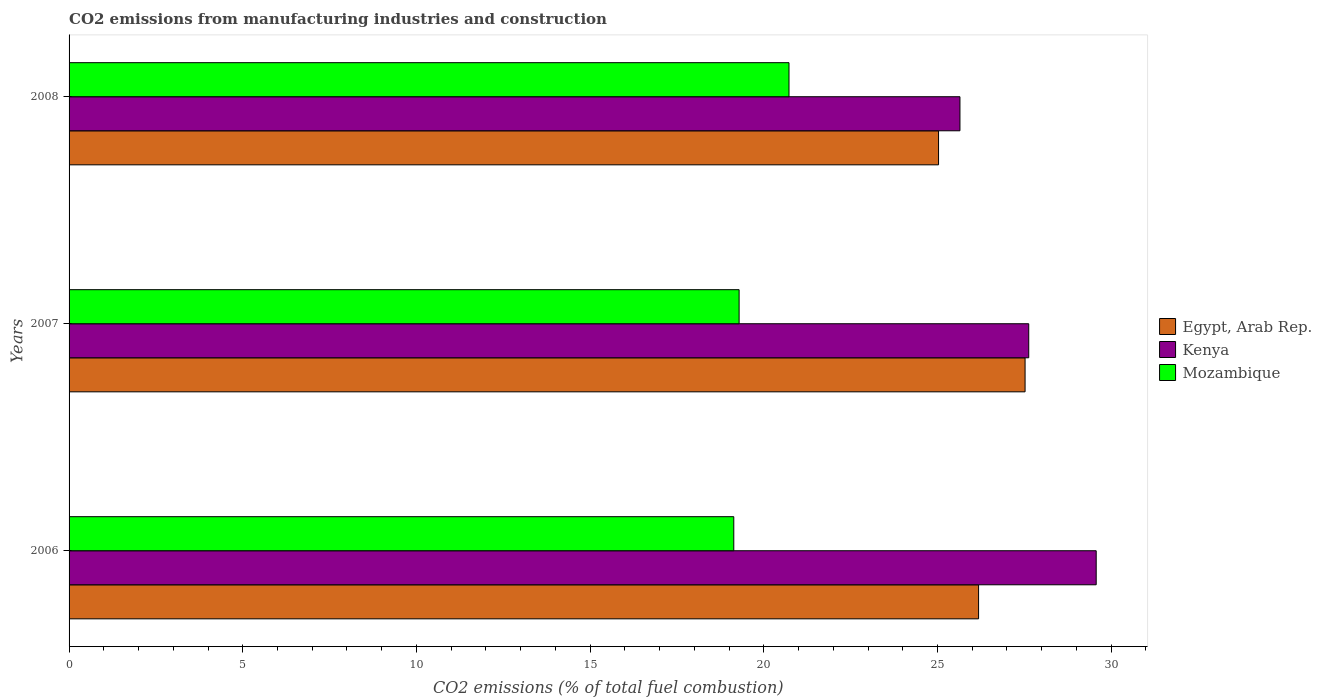Are the number of bars on each tick of the Y-axis equal?
Ensure brevity in your answer.  Yes. How many bars are there on the 3rd tick from the bottom?
Your response must be concise. 3. What is the label of the 3rd group of bars from the top?
Offer a terse response. 2006. What is the amount of CO2 emitted in Egypt, Arab Rep. in 2008?
Provide a succinct answer. 25.03. Across all years, what is the maximum amount of CO2 emitted in Egypt, Arab Rep.?
Offer a very short reply. 27.52. Across all years, what is the minimum amount of CO2 emitted in Egypt, Arab Rep.?
Provide a succinct answer. 25.03. In which year was the amount of CO2 emitted in Egypt, Arab Rep. minimum?
Offer a very short reply. 2008. What is the total amount of CO2 emitted in Kenya in the graph?
Your response must be concise. 82.84. What is the difference between the amount of CO2 emitted in Mozambique in 2006 and that in 2007?
Keep it short and to the point. -0.15. What is the difference between the amount of CO2 emitted in Egypt, Arab Rep. in 2006 and the amount of CO2 emitted in Mozambique in 2007?
Keep it short and to the point. 6.89. What is the average amount of CO2 emitted in Mozambique per year?
Provide a short and direct response. 19.72. In the year 2006, what is the difference between the amount of CO2 emitted in Kenya and amount of CO2 emitted in Mozambique?
Offer a terse response. 10.43. In how many years, is the amount of CO2 emitted in Kenya greater than 16 %?
Your answer should be compact. 3. What is the ratio of the amount of CO2 emitted in Mozambique in 2007 to that in 2008?
Keep it short and to the point. 0.93. Is the difference between the amount of CO2 emitted in Kenya in 2006 and 2007 greater than the difference between the amount of CO2 emitted in Mozambique in 2006 and 2007?
Give a very brief answer. Yes. What is the difference between the highest and the second highest amount of CO2 emitted in Mozambique?
Provide a short and direct response. 1.44. What is the difference between the highest and the lowest amount of CO2 emitted in Mozambique?
Offer a terse response. 1.59. In how many years, is the amount of CO2 emitted in Egypt, Arab Rep. greater than the average amount of CO2 emitted in Egypt, Arab Rep. taken over all years?
Provide a short and direct response. 1. What does the 2nd bar from the top in 2006 represents?
Provide a short and direct response. Kenya. What does the 3rd bar from the bottom in 2007 represents?
Ensure brevity in your answer.  Mozambique. Is it the case that in every year, the sum of the amount of CO2 emitted in Kenya and amount of CO2 emitted in Mozambique is greater than the amount of CO2 emitted in Egypt, Arab Rep.?
Your response must be concise. Yes. What is the difference between two consecutive major ticks on the X-axis?
Provide a succinct answer. 5. How many legend labels are there?
Provide a short and direct response. 3. How are the legend labels stacked?
Make the answer very short. Vertical. What is the title of the graph?
Give a very brief answer. CO2 emissions from manufacturing industries and construction. Does "Macedonia" appear as one of the legend labels in the graph?
Your response must be concise. No. What is the label or title of the X-axis?
Keep it short and to the point. CO2 emissions (% of total fuel combustion). What is the label or title of the Y-axis?
Give a very brief answer. Years. What is the CO2 emissions (% of total fuel combustion) in Egypt, Arab Rep. in 2006?
Ensure brevity in your answer.  26.18. What is the CO2 emissions (% of total fuel combustion) of Kenya in 2006?
Offer a very short reply. 29.57. What is the CO2 emissions (% of total fuel combustion) of Mozambique in 2006?
Your answer should be compact. 19.14. What is the CO2 emissions (% of total fuel combustion) in Egypt, Arab Rep. in 2007?
Your answer should be very brief. 27.52. What is the CO2 emissions (% of total fuel combustion) in Kenya in 2007?
Your answer should be compact. 27.63. What is the CO2 emissions (% of total fuel combustion) of Mozambique in 2007?
Keep it short and to the point. 19.29. What is the CO2 emissions (% of total fuel combustion) of Egypt, Arab Rep. in 2008?
Provide a succinct answer. 25.03. What is the CO2 emissions (% of total fuel combustion) of Kenya in 2008?
Keep it short and to the point. 25.65. What is the CO2 emissions (% of total fuel combustion) in Mozambique in 2008?
Make the answer very short. 20.73. Across all years, what is the maximum CO2 emissions (% of total fuel combustion) in Egypt, Arab Rep.?
Give a very brief answer. 27.52. Across all years, what is the maximum CO2 emissions (% of total fuel combustion) of Kenya?
Keep it short and to the point. 29.57. Across all years, what is the maximum CO2 emissions (% of total fuel combustion) of Mozambique?
Make the answer very short. 20.73. Across all years, what is the minimum CO2 emissions (% of total fuel combustion) in Egypt, Arab Rep.?
Your answer should be compact. 25.03. Across all years, what is the minimum CO2 emissions (% of total fuel combustion) in Kenya?
Offer a very short reply. 25.65. Across all years, what is the minimum CO2 emissions (% of total fuel combustion) of Mozambique?
Keep it short and to the point. 19.14. What is the total CO2 emissions (% of total fuel combustion) of Egypt, Arab Rep. in the graph?
Offer a very short reply. 78.74. What is the total CO2 emissions (% of total fuel combustion) in Kenya in the graph?
Give a very brief answer. 82.84. What is the total CO2 emissions (% of total fuel combustion) of Mozambique in the graph?
Your answer should be very brief. 59.15. What is the difference between the CO2 emissions (% of total fuel combustion) in Egypt, Arab Rep. in 2006 and that in 2007?
Provide a succinct answer. -1.34. What is the difference between the CO2 emissions (% of total fuel combustion) in Kenya in 2006 and that in 2007?
Ensure brevity in your answer.  1.94. What is the difference between the CO2 emissions (% of total fuel combustion) in Mozambique in 2006 and that in 2007?
Ensure brevity in your answer.  -0.15. What is the difference between the CO2 emissions (% of total fuel combustion) of Egypt, Arab Rep. in 2006 and that in 2008?
Offer a very short reply. 1.15. What is the difference between the CO2 emissions (% of total fuel combustion) in Kenya in 2006 and that in 2008?
Ensure brevity in your answer.  3.92. What is the difference between the CO2 emissions (% of total fuel combustion) in Mozambique in 2006 and that in 2008?
Give a very brief answer. -1.59. What is the difference between the CO2 emissions (% of total fuel combustion) in Egypt, Arab Rep. in 2007 and that in 2008?
Give a very brief answer. 2.49. What is the difference between the CO2 emissions (% of total fuel combustion) in Kenya in 2007 and that in 2008?
Provide a succinct answer. 1.98. What is the difference between the CO2 emissions (% of total fuel combustion) in Mozambique in 2007 and that in 2008?
Offer a very short reply. -1.44. What is the difference between the CO2 emissions (% of total fuel combustion) of Egypt, Arab Rep. in 2006 and the CO2 emissions (% of total fuel combustion) of Kenya in 2007?
Offer a terse response. -1.44. What is the difference between the CO2 emissions (% of total fuel combustion) in Egypt, Arab Rep. in 2006 and the CO2 emissions (% of total fuel combustion) in Mozambique in 2007?
Ensure brevity in your answer.  6.89. What is the difference between the CO2 emissions (% of total fuel combustion) of Kenya in 2006 and the CO2 emissions (% of total fuel combustion) of Mozambique in 2007?
Ensure brevity in your answer.  10.28. What is the difference between the CO2 emissions (% of total fuel combustion) of Egypt, Arab Rep. in 2006 and the CO2 emissions (% of total fuel combustion) of Kenya in 2008?
Make the answer very short. 0.54. What is the difference between the CO2 emissions (% of total fuel combustion) of Egypt, Arab Rep. in 2006 and the CO2 emissions (% of total fuel combustion) of Mozambique in 2008?
Your answer should be very brief. 5.46. What is the difference between the CO2 emissions (% of total fuel combustion) of Kenya in 2006 and the CO2 emissions (% of total fuel combustion) of Mozambique in 2008?
Offer a terse response. 8.84. What is the difference between the CO2 emissions (% of total fuel combustion) of Egypt, Arab Rep. in 2007 and the CO2 emissions (% of total fuel combustion) of Kenya in 2008?
Your answer should be very brief. 1.88. What is the difference between the CO2 emissions (% of total fuel combustion) in Egypt, Arab Rep. in 2007 and the CO2 emissions (% of total fuel combustion) in Mozambique in 2008?
Your response must be concise. 6.8. What is the difference between the CO2 emissions (% of total fuel combustion) of Kenya in 2007 and the CO2 emissions (% of total fuel combustion) of Mozambique in 2008?
Make the answer very short. 6.9. What is the average CO2 emissions (% of total fuel combustion) of Egypt, Arab Rep. per year?
Give a very brief answer. 26.25. What is the average CO2 emissions (% of total fuel combustion) in Kenya per year?
Your answer should be very brief. 27.61. What is the average CO2 emissions (% of total fuel combustion) in Mozambique per year?
Offer a very short reply. 19.72. In the year 2006, what is the difference between the CO2 emissions (% of total fuel combustion) of Egypt, Arab Rep. and CO2 emissions (% of total fuel combustion) of Kenya?
Your answer should be compact. -3.39. In the year 2006, what is the difference between the CO2 emissions (% of total fuel combustion) of Egypt, Arab Rep. and CO2 emissions (% of total fuel combustion) of Mozambique?
Provide a succinct answer. 7.05. In the year 2006, what is the difference between the CO2 emissions (% of total fuel combustion) in Kenya and CO2 emissions (% of total fuel combustion) in Mozambique?
Give a very brief answer. 10.43. In the year 2007, what is the difference between the CO2 emissions (% of total fuel combustion) of Egypt, Arab Rep. and CO2 emissions (% of total fuel combustion) of Kenya?
Make the answer very short. -0.1. In the year 2007, what is the difference between the CO2 emissions (% of total fuel combustion) of Egypt, Arab Rep. and CO2 emissions (% of total fuel combustion) of Mozambique?
Make the answer very short. 8.23. In the year 2007, what is the difference between the CO2 emissions (% of total fuel combustion) in Kenya and CO2 emissions (% of total fuel combustion) in Mozambique?
Offer a very short reply. 8.34. In the year 2008, what is the difference between the CO2 emissions (% of total fuel combustion) of Egypt, Arab Rep. and CO2 emissions (% of total fuel combustion) of Kenya?
Ensure brevity in your answer.  -0.62. In the year 2008, what is the difference between the CO2 emissions (% of total fuel combustion) in Egypt, Arab Rep. and CO2 emissions (% of total fuel combustion) in Mozambique?
Your answer should be very brief. 4.31. In the year 2008, what is the difference between the CO2 emissions (% of total fuel combustion) of Kenya and CO2 emissions (% of total fuel combustion) of Mozambique?
Provide a succinct answer. 4.92. What is the ratio of the CO2 emissions (% of total fuel combustion) of Egypt, Arab Rep. in 2006 to that in 2007?
Give a very brief answer. 0.95. What is the ratio of the CO2 emissions (% of total fuel combustion) in Kenya in 2006 to that in 2007?
Make the answer very short. 1.07. What is the ratio of the CO2 emissions (% of total fuel combustion) of Egypt, Arab Rep. in 2006 to that in 2008?
Ensure brevity in your answer.  1.05. What is the ratio of the CO2 emissions (% of total fuel combustion) of Kenya in 2006 to that in 2008?
Your answer should be very brief. 1.15. What is the ratio of the CO2 emissions (% of total fuel combustion) in Mozambique in 2006 to that in 2008?
Your answer should be very brief. 0.92. What is the ratio of the CO2 emissions (% of total fuel combustion) of Egypt, Arab Rep. in 2007 to that in 2008?
Keep it short and to the point. 1.1. What is the ratio of the CO2 emissions (% of total fuel combustion) in Kenya in 2007 to that in 2008?
Your answer should be compact. 1.08. What is the ratio of the CO2 emissions (% of total fuel combustion) of Mozambique in 2007 to that in 2008?
Your response must be concise. 0.93. What is the difference between the highest and the second highest CO2 emissions (% of total fuel combustion) of Egypt, Arab Rep.?
Make the answer very short. 1.34. What is the difference between the highest and the second highest CO2 emissions (% of total fuel combustion) in Kenya?
Make the answer very short. 1.94. What is the difference between the highest and the second highest CO2 emissions (% of total fuel combustion) in Mozambique?
Provide a succinct answer. 1.44. What is the difference between the highest and the lowest CO2 emissions (% of total fuel combustion) of Egypt, Arab Rep.?
Give a very brief answer. 2.49. What is the difference between the highest and the lowest CO2 emissions (% of total fuel combustion) in Kenya?
Offer a terse response. 3.92. What is the difference between the highest and the lowest CO2 emissions (% of total fuel combustion) of Mozambique?
Provide a short and direct response. 1.59. 